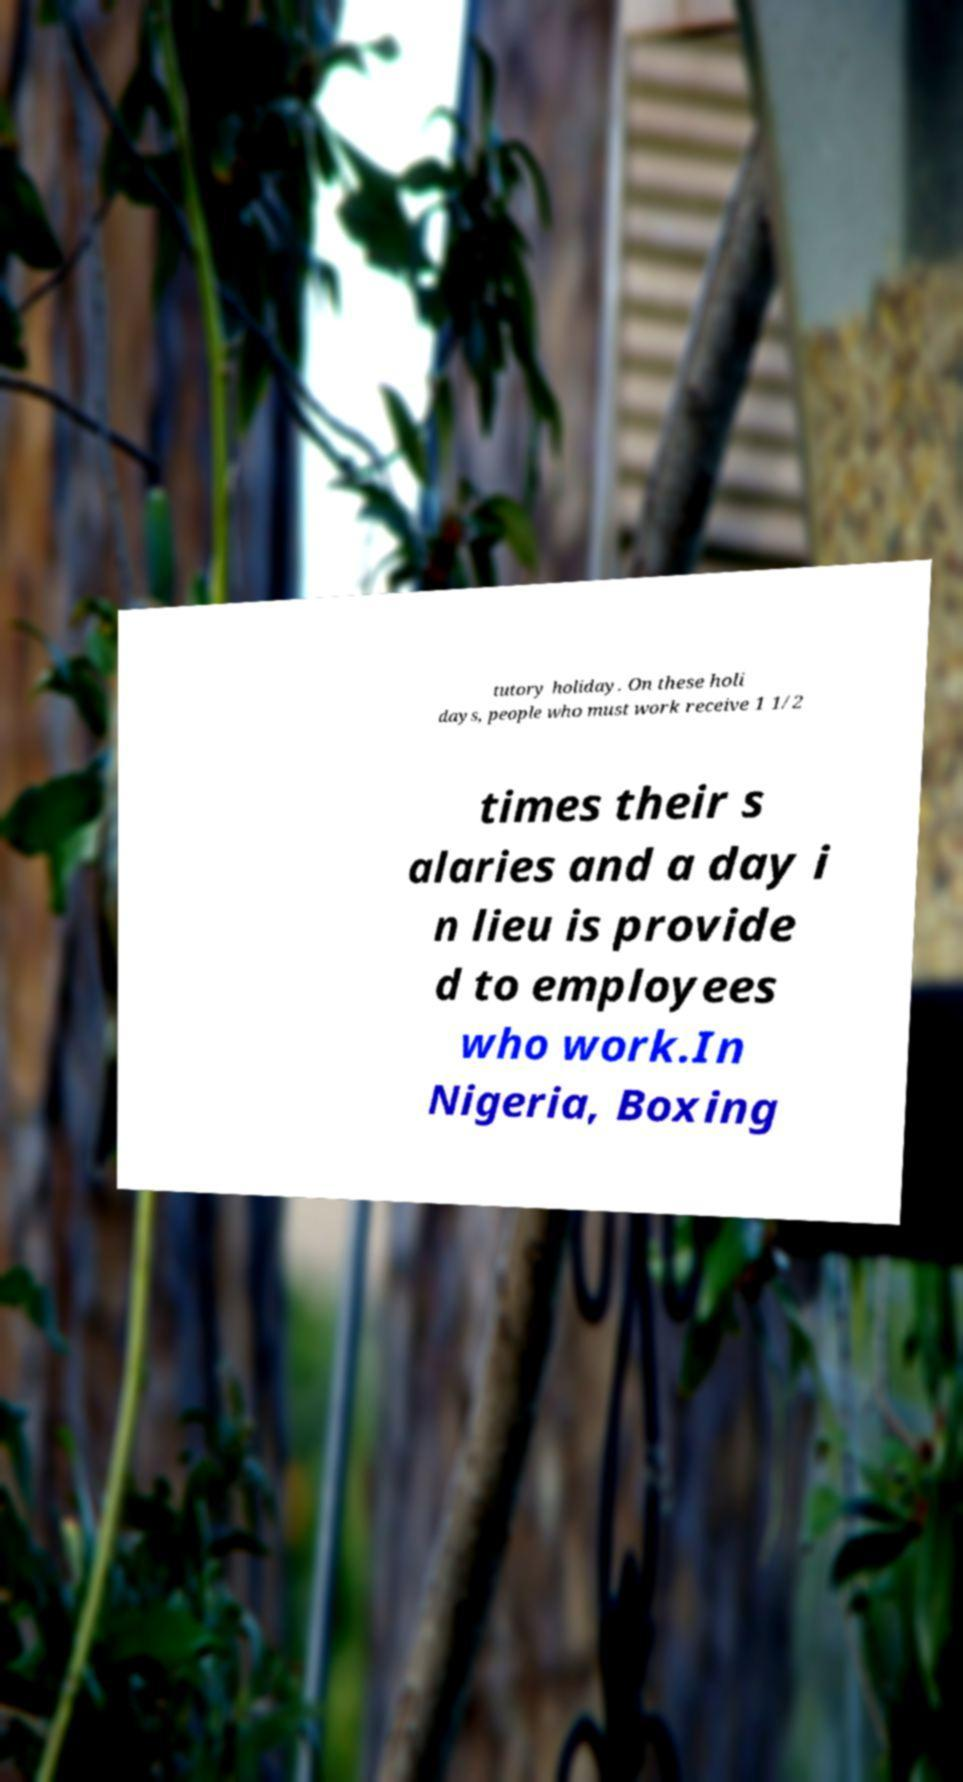Can you accurately transcribe the text from the provided image for me? tutory holiday. On these holi days, people who must work receive 1 1/2 times their s alaries and a day i n lieu is provide d to employees who work.In Nigeria, Boxing 